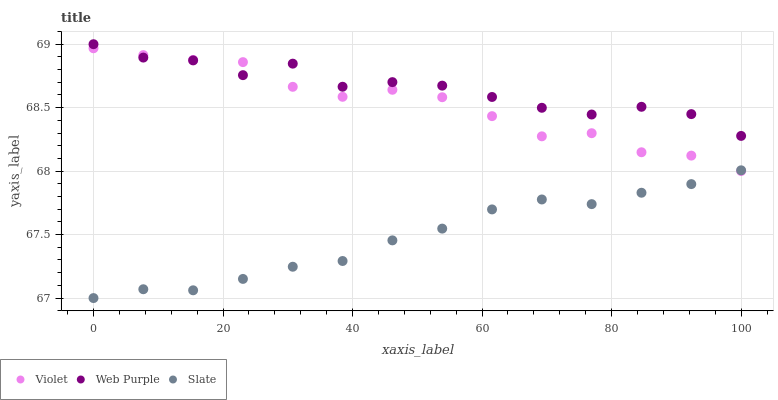Does Slate have the minimum area under the curve?
Answer yes or no. Yes. Does Web Purple have the maximum area under the curve?
Answer yes or no. Yes. Does Violet have the minimum area under the curve?
Answer yes or no. No. Does Violet have the maximum area under the curve?
Answer yes or no. No. Is Slate the smoothest?
Answer yes or no. Yes. Is Web Purple the roughest?
Answer yes or no. Yes. Is Violet the smoothest?
Answer yes or no. No. Is Violet the roughest?
Answer yes or no. No. Does Slate have the lowest value?
Answer yes or no. Yes. Does Violet have the lowest value?
Answer yes or no. No. Does Web Purple have the highest value?
Answer yes or no. Yes. Does Violet have the highest value?
Answer yes or no. No. Is Slate less than Web Purple?
Answer yes or no. Yes. Is Web Purple greater than Slate?
Answer yes or no. Yes. Does Web Purple intersect Violet?
Answer yes or no. Yes. Is Web Purple less than Violet?
Answer yes or no. No. Is Web Purple greater than Violet?
Answer yes or no. No. Does Slate intersect Web Purple?
Answer yes or no. No. 